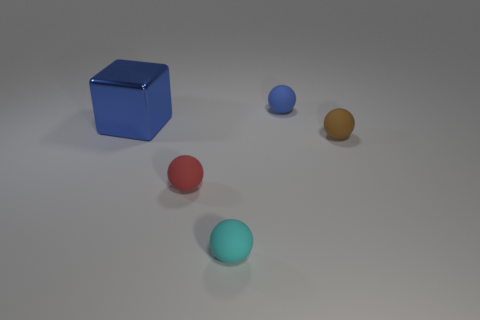Are there any other things that are the same material as the big blue block?
Give a very brief answer. No. There is a sphere that is the same color as the big block; what is its size?
Your answer should be very brief. Small. There is a blue thing in front of the rubber object that is behind the small matte ball that is right of the small blue matte ball; what is its size?
Make the answer very short. Large. There is a cyan rubber thing; is its size the same as the blue object to the right of the red sphere?
Offer a terse response. Yes. There is a small object in front of the small red matte sphere; what color is it?
Make the answer very short. Cyan. There is a blue object to the left of the tiny cyan thing; what is its shape?
Offer a very short reply. Cube. What number of red objects are either tiny rubber balls or big things?
Ensure brevity in your answer.  1. Do the tiny red ball and the large cube have the same material?
Offer a terse response. No. How many blocks are in front of the tiny cyan rubber object?
Make the answer very short. 0. What is the material of the thing that is both on the left side of the cyan sphere and behind the tiny brown ball?
Offer a terse response. Metal. 